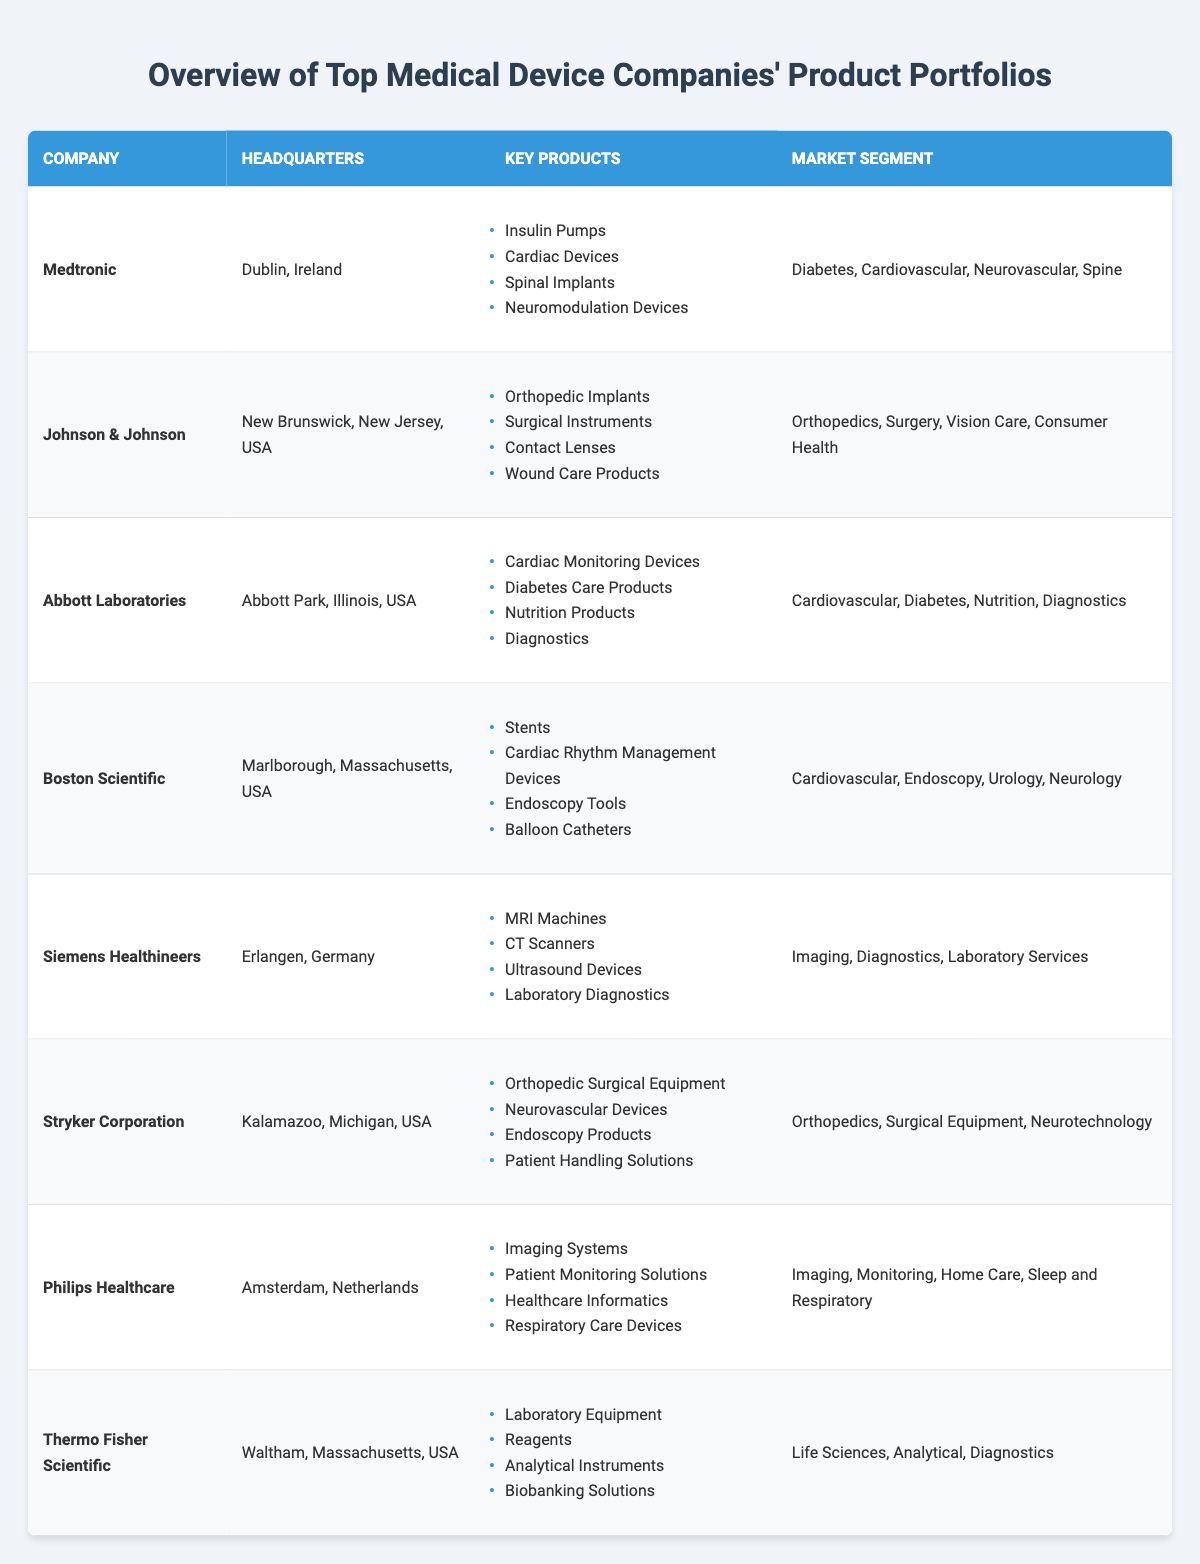What is the headquarters of Siemens Healthineers? The headquarters of Siemens Healthineers is listed in the table under the 'Headquarters' column. It shows "Erlangen, Germany."
Answer: Erlangen, Germany Which company has a product portfolio focusing on Imaging and Diagnostics? To find the company, I check the 'Market Segment' column for 'Imaging' and 'Diagnostics.' Siemens Healthineers has both segments in its portfolio.
Answer: Siemens Healthineers How many key products does Abbott Laboratories have listed? By looking at the 'Key Products' for Abbott Laboratories, I can count the items listed: Cardiac Monitoring Devices, Diabetes Care Products, Nutrition Products, Diagnostics. That's 4 total.
Answer: 4 Is Stryker Corporation involved in Neurotechnology? I can confirm if Stryker Corporation is involved in Neurotechnology by checking the 'Market Segment' column, which includes "Neurotechnology."
Answer: Yes What are the total number of market segments represented in the table? First, I list the unique market segments from each company: Diabetes, Cardiovascular, Neurovascular, Spine, Orthopedics, Surgery, Vision Care, Consumer Health, Nutrition, Diagnostics, Endoscopy, Urology, Imaging, Laboratory Services, Monitoring, Home Care, Sleep and Respiratory, Life Sciences, Analytical. There are 18 unique segments.
Answer: 18 Which company has the largest number of diverse market segments based on the table? I analyze the 'Market Segment' column for each company to determine how many unique segments each is involved in. Medtronic has 4, Johnson & Johnson has 4, Abbott Laboratories has 4, Boston Scientific has 4, Siemens Healthineers has 3, Stryker Corporation has 3, Philips Healthcare has 4, and Thermo Fisher Scientific has 3, thus several companies have the maximum of 4 segments.
Answer: Medtronic, Johnson & Johnson, Abbott Laboratories, Boston Scientific, Philips Healthcare Are all companies headquartered in the United States? I check the 'Headquarters' for each company. Several companies, such as Medtronic and Siemens Healthineers, are headquartered outside the United States.
Answer: No What are the key products of Johnson & Johnson? The 'Key Products' for Johnson & Johnson can be directly read from the table: Orthopedic Implants, Surgical Instruments, Contact Lenses, Wound Care Products.
Answer: Orthopedic Implants, Surgical Instruments, Contact Lenses, Wound Care Products Which products are common between Abbott Laboratories and Boston Scientific? I look for overlapping products in the 'Key Products' columns for both companies. There are no shared products in the lists; all are unique to each company.
Answer: None Count the number of companies that specialize in Cardiovascular products. I identify companies in the table with 'Cardiovascular' in their 'Market Segment': Medtronic, Abbott Laboratories, Boston Scientific. That results in 3 companies involved in Cardiovascular products.
Answer: 3 